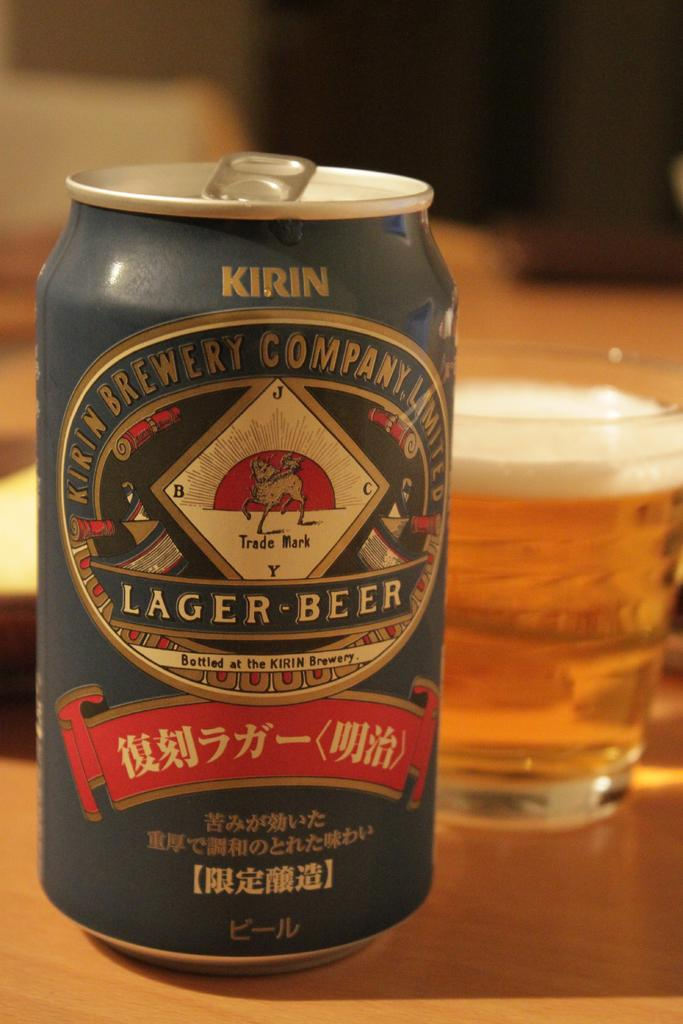<image>
Relay a brief, clear account of the picture shown. A can of Kirin Brewery lager beer sits on a wooden table near a glass of beer. 